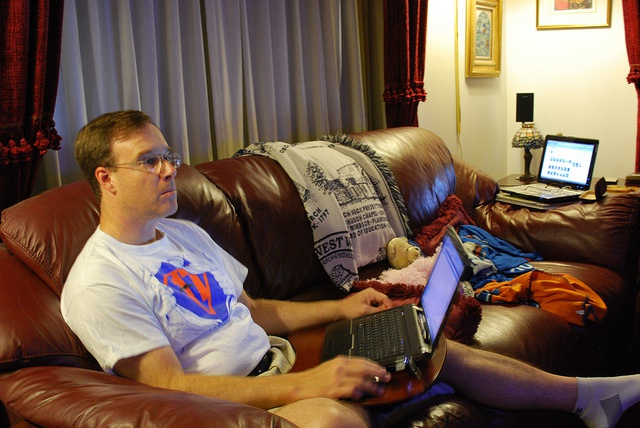Describe the objects in this image and their specific colors. I can see couch in black, maroon, and tan tones, people in black, olive, darkgray, and beige tones, laptop in black, violet, and darkgreen tones, laptop in black, white, tan, and lightblue tones, and teddy bear in black, olive, and tan tones in this image. 